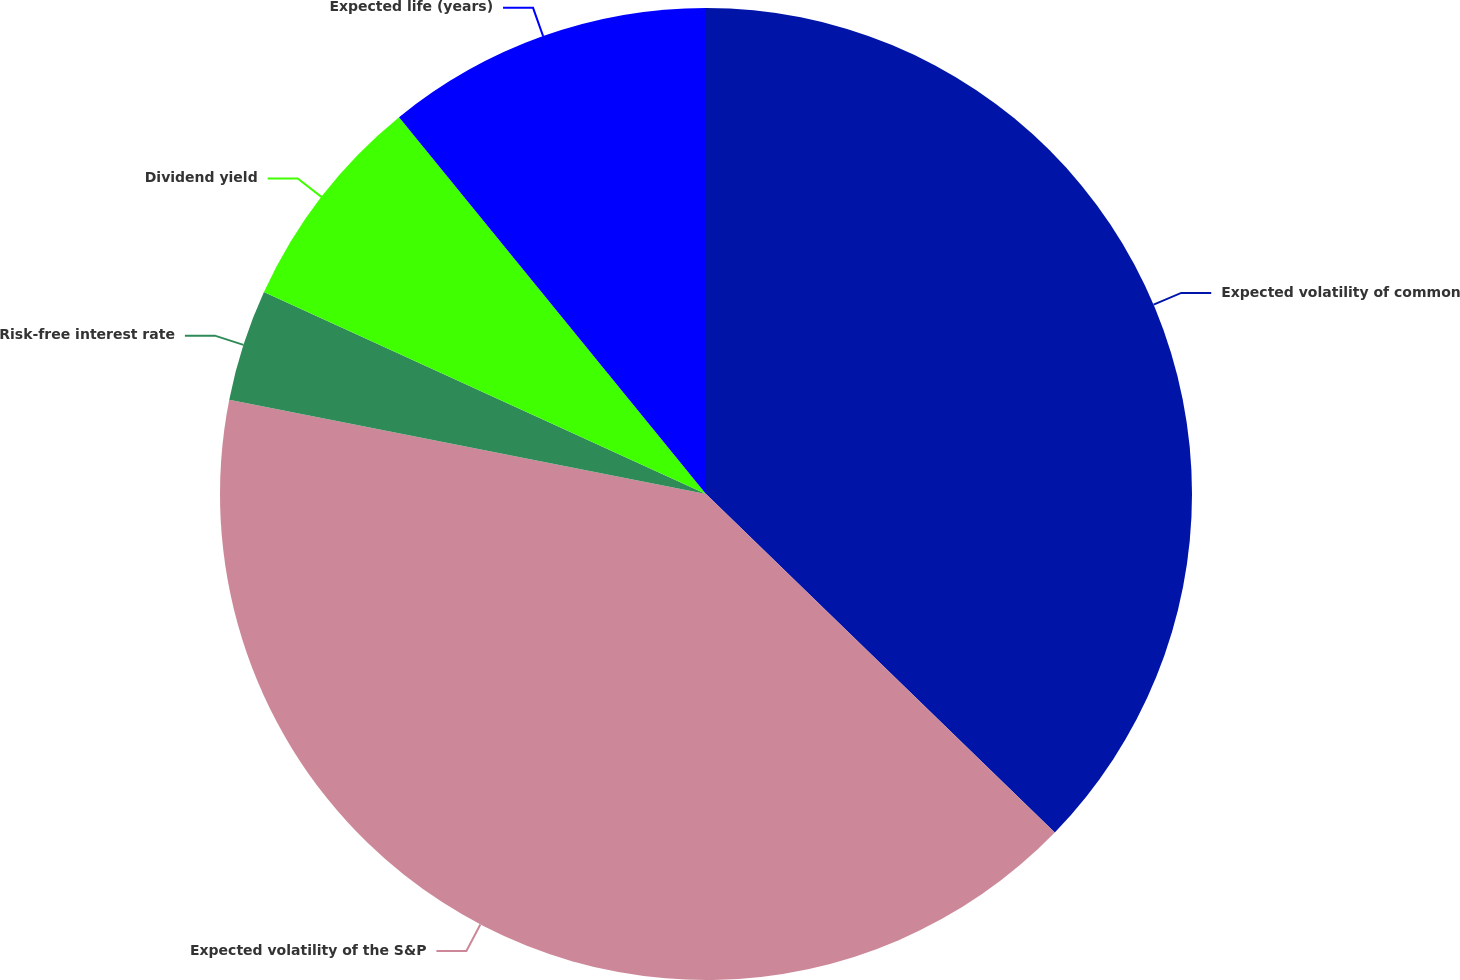Convert chart to OTSL. <chart><loc_0><loc_0><loc_500><loc_500><pie_chart><fcel>Expected volatility of common<fcel>Expected volatility of the S&P<fcel>Risk-free interest rate<fcel>Dividend yield<fcel>Expected life (years)<nl><fcel>37.26%<fcel>40.85%<fcel>3.71%<fcel>7.3%<fcel>10.88%<nl></chart> 